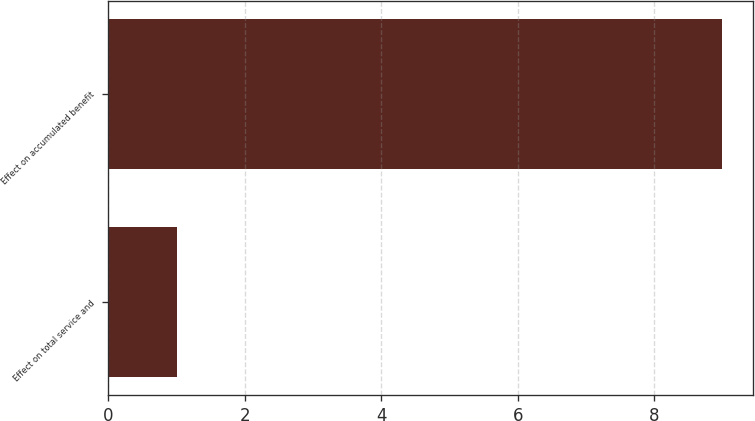Convert chart. <chart><loc_0><loc_0><loc_500><loc_500><bar_chart><fcel>Effect on total service and<fcel>Effect on accumulated benefit<nl><fcel>1<fcel>9<nl></chart> 